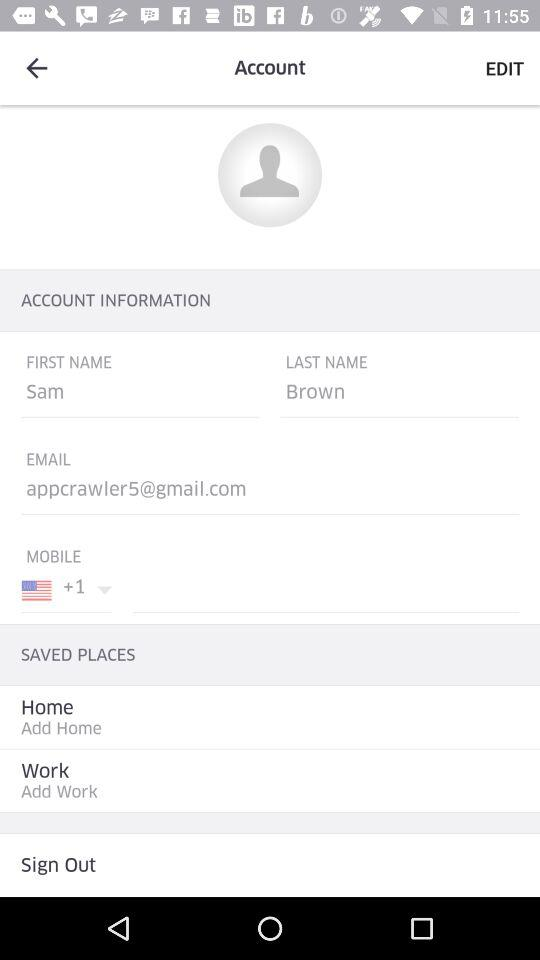What is the user name? The user name is Sam Brown. 